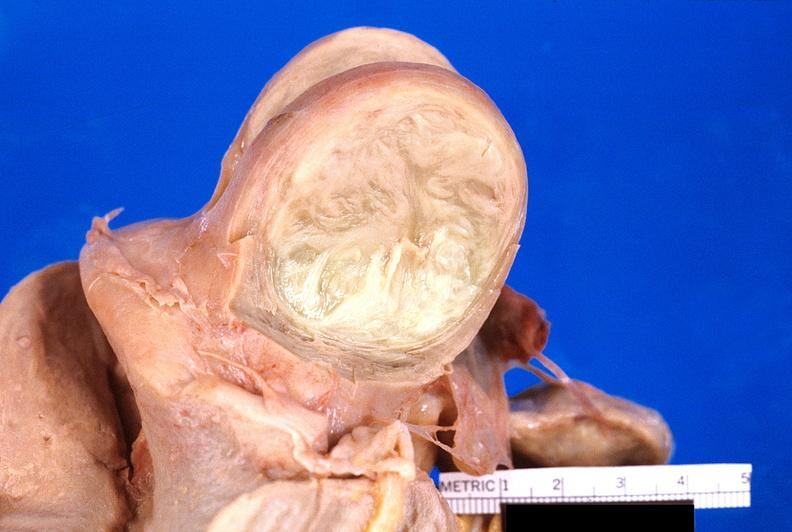what does this image show?
Answer the question using a single word or phrase. Uterus 